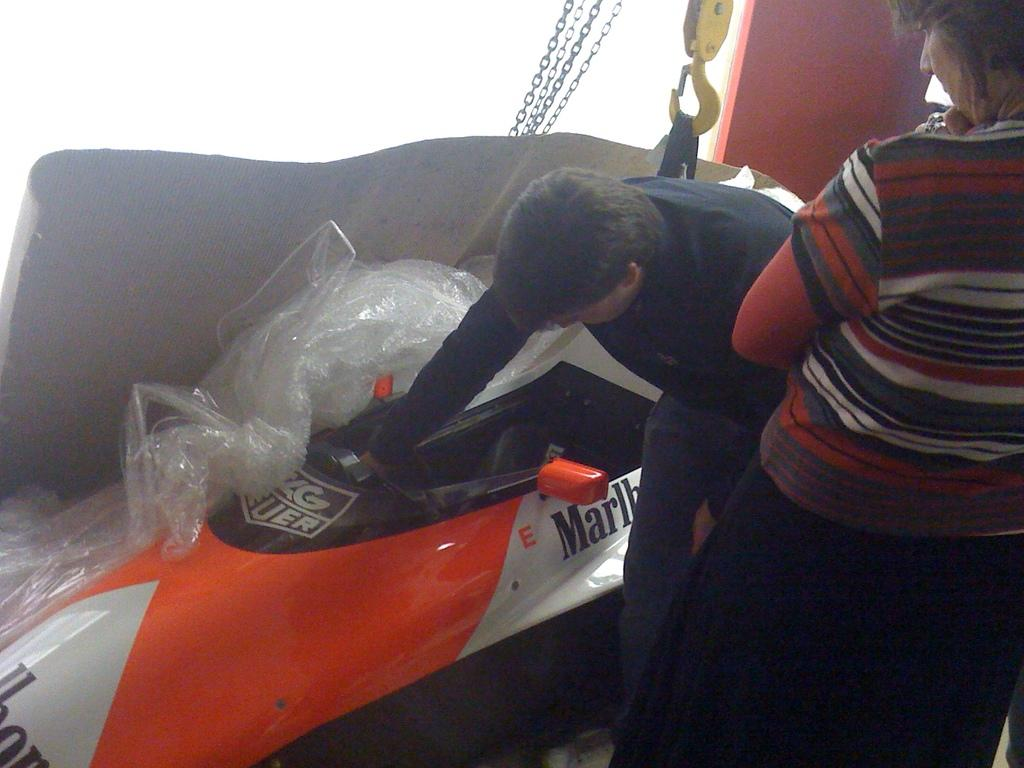How many people are in the image? There are two persons standing on the floor. What is one person holding in the image? One person is holding a car. What other objects can be seen in the image? There are boards and a crane present in the image. What is attached to the crane in the image? There is thread attached to the crane. What type of box can be seen on the person's head in the image? There is no box or person with a box on their head in the image. 